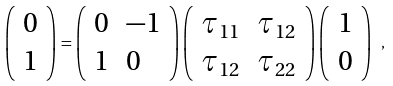<formula> <loc_0><loc_0><loc_500><loc_500>\left ( \begin{array} { l l } 0 \\ 1 \end{array} \right ) = \left ( \begin{array} { l l } 0 & - 1 \\ 1 & 0 \end{array} \right ) \left ( \begin{array} { l l } \tau _ { 1 1 } & \tau _ { 1 2 } \\ \tau _ { 1 2 } & \tau _ { 2 2 } \end{array} \right ) \left ( \begin{array} { l l } 1 \\ 0 \end{array} \right ) \ ,</formula> 